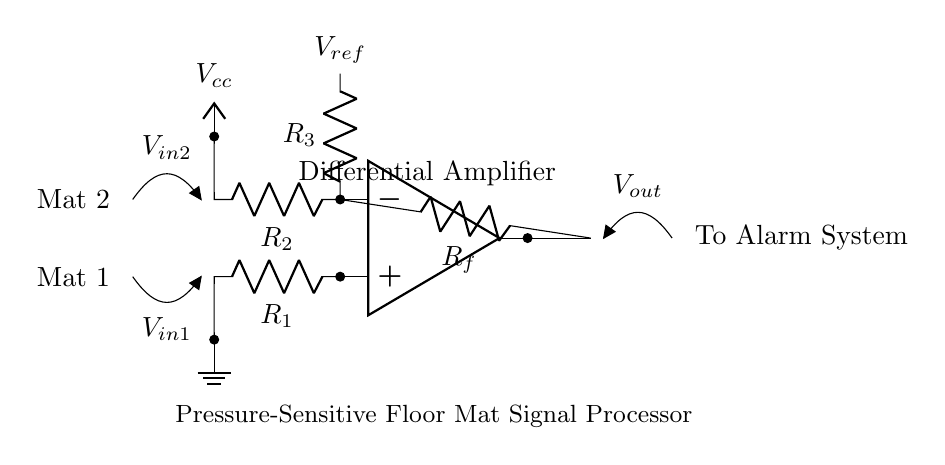What type of amplifier is shown in the circuit? The circuit diagram depicts a differential amplifier, which is designed to amplify the difference between two input voltage signals. This is confirmed by the presence of two input resistors and the operational amplifier symbol.
Answer: Differential amplifier What are the values of the input resistors? The input resistors are labeled as R1 and R2, but their specific values are not provided in the diagram. However, it is clear they are fundamental components in determining the gain of the differential amplifier along with the feedback resistor.
Answer: R1, R2 What is the role of the feedback resistor? The feedback resistor, labeled Rf, connects the output of the amplifier back to its inverting input. This configuration helps to stabilize the gain of the amplifier and allows for precise control over the amplification of the input signals.
Answer: Feedback stabilization How do the input voltages relate to the output voltage? The output voltage, denoted as Vout, is determined by the difference between the two input voltages (Vin1 and Vin2) scaled by the gain set by the resistors. This relationship illustrates the function of the differential amplifier in processing the signals simultaneously from the pressure-sensitive floor mats.
Answer: Difference amplification What is the purpose of the reference voltage in the circuit? The reference voltage, labeled as Vref, provides a baseline for the operational amplifier. This allows the amplifier to differentiate between the signals from the two mats more effectively, helping to minimize false alarms by adjusting the threshold level.
Answer: Signal baseline How is the circuit powered? The circuit is powered by a positive voltage supply labeled as Vcc, which is commonly used to provide the necessary operating voltage for the operational amplifier to function correctly and amplify the input signals.
Answer: Vcc 